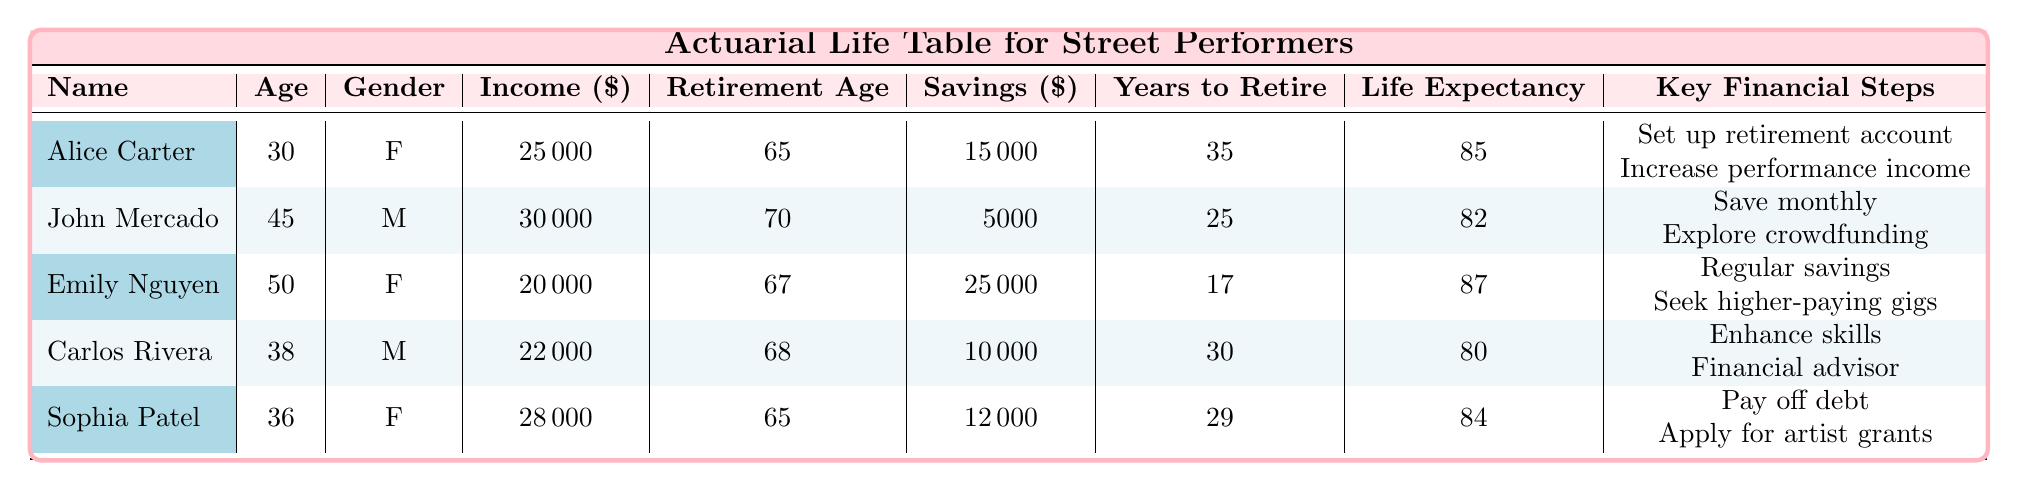What is the retirement age for Alice Carter? The table shows that Alice Carter's retirement age is listed directly in the relevant column.
Answer: 65 How much savings does John Mercado have? According to the table, John's savings amount is provided clearly.
Answer: 5000 Which performer has the highest estimated life expectancy? The life expectancy for each performer can be compared directly from the table. Emily Nguyen has the highest life expectancy at 87 years.
Answer: 87 What is the average current income of the performers listed? To find the average current income, add the income of all performers (25000 + 30000 + 20000 + 22000 + 28000 = 125000) and divide by the number of performers (5). The average is 125000/5 = 25000.
Answer: 25000 Is Sophia Patel's retirement age earlier than that of Carlos Rivera? Sophia Patel's retirement age is 65, while Carlos Rivera's is 68. Since 65 is less than 68, the answer is yes.
Answer: Yes How many years until retirement does Emily Nguyen have? The table specifies the number of years until retirement for each performer, and for Emily Nguyen, it is clearly indicated as 17 years.
Answer: 17 If Alice Carter saves an additional 2000 every year, what will her total savings be at retirement age? Alice currently has 15000 in savings and has 35 years until retirement. If she saves an additional 2000 per year, her total savings at retirement will be 15000 + (2000 * 35) = 15000 + 70000 = 85000.
Answer: 85000 What are the key financial steps for Carlos Rivera? The table outlines the key financial steps for each performer, listing specific actions Carlos plans to take which can be found in the relevant column for his entry.
Answer: Enhance skills, Financial advisor, Track performance revenue, Diversify income sources Is Emily Nguyen a male performer? The gender of Emily Nguyen is clearly specified in the table, and it states she is female, so the answer is no.
Answer: No 